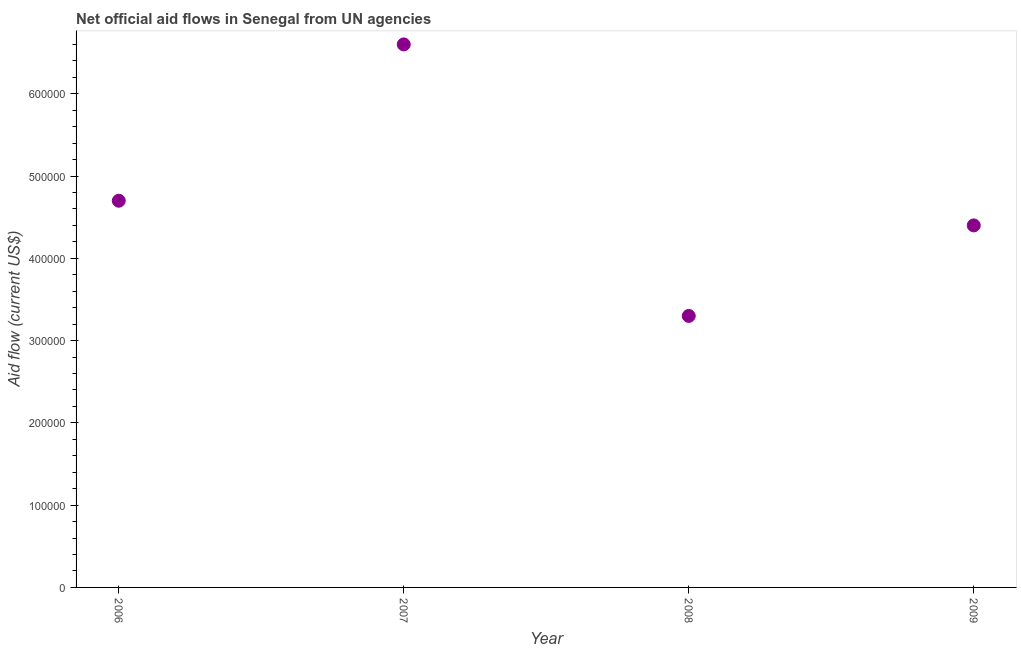What is the net official flows from un agencies in 2007?
Offer a very short reply. 6.60e+05. Across all years, what is the maximum net official flows from un agencies?
Provide a short and direct response. 6.60e+05. Across all years, what is the minimum net official flows from un agencies?
Give a very brief answer. 3.30e+05. In which year was the net official flows from un agencies minimum?
Ensure brevity in your answer.  2008. What is the sum of the net official flows from un agencies?
Offer a terse response. 1.90e+06. What is the difference between the net official flows from un agencies in 2006 and 2008?
Offer a very short reply. 1.40e+05. What is the average net official flows from un agencies per year?
Your answer should be very brief. 4.75e+05. What is the median net official flows from un agencies?
Ensure brevity in your answer.  4.55e+05. Is the net official flows from un agencies in 2006 less than that in 2007?
Keep it short and to the point. Yes. What is the difference between the highest and the second highest net official flows from un agencies?
Your answer should be very brief. 1.90e+05. Is the sum of the net official flows from un agencies in 2006 and 2009 greater than the maximum net official flows from un agencies across all years?
Offer a terse response. Yes. What is the difference between the highest and the lowest net official flows from un agencies?
Provide a succinct answer. 3.30e+05. How many years are there in the graph?
Ensure brevity in your answer.  4. Are the values on the major ticks of Y-axis written in scientific E-notation?
Offer a terse response. No. Does the graph contain grids?
Offer a very short reply. No. What is the title of the graph?
Your answer should be very brief. Net official aid flows in Senegal from UN agencies. What is the Aid flow (current US$) in 2006?
Provide a short and direct response. 4.70e+05. What is the Aid flow (current US$) in 2008?
Provide a short and direct response. 3.30e+05. What is the Aid flow (current US$) in 2009?
Provide a succinct answer. 4.40e+05. What is the difference between the Aid flow (current US$) in 2006 and 2008?
Offer a very short reply. 1.40e+05. What is the difference between the Aid flow (current US$) in 2007 and 2008?
Offer a very short reply. 3.30e+05. What is the difference between the Aid flow (current US$) in 2007 and 2009?
Your response must be concise. 2.20e+05. What is the difference between the Aid flow (current US$) in 2008 and 2009?
Offer a very short reply. -1.10e+05. What is the ratio of the Aid flow (current US$) in 2006 to that in 2007?
Your answer should be compact. 0.71. What is the ratio of the Aid flow (current US$) in 2006 to that in 2008?
Ensure brevity in your answer.  1.42. What is the ratio of the Aid flow (current US$) in 2006 to that in 2009?
Your response must be concise. 1.07. What is the ratio of the Aid flow (current US$) in 2007 to that in 2008?
Provide a short and direct response. 2. What is the ratio of the Aid flow (current US$) in 2007 to that in 2009?
Your answer should be compact. 1.5. 